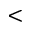Convert formula to latex. <formula><loc_0><loc_0><loc_500><loc_500><</formula> 